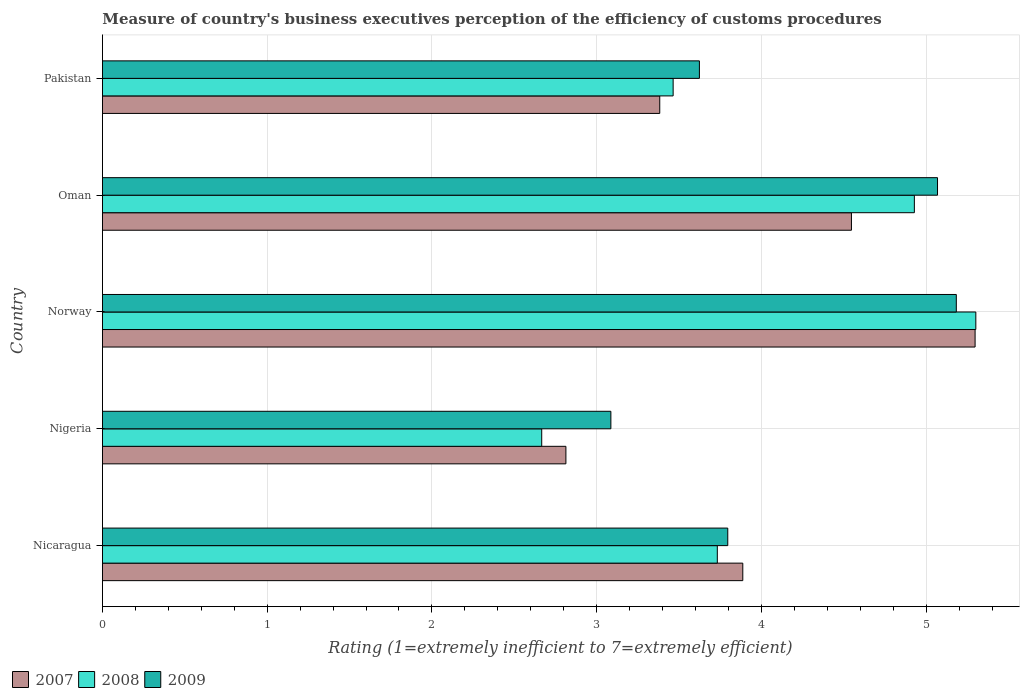How many different coloured bars are there?
Your answer should be compact. 3. How many bars are there on the 3rd tick from the top?
Offer a terse response. 3. How many bars are there on the 3rd tick from the bottom?
Your answer should be compact. 3. What is the label of the 2nd group of bars from the top?
Ensure brevity in your answer.  Oman. What is the rating of the efficiency of customs procedure in 2008 in Oman?
Your response must be concise. 4.93. Across all countries, what is the maximum rating of the efficiency of customs procedure in 2008?
Offer a terse response. 5.3. Across all countries, what is the minimum rating of the efficiency of customs procedure in 2008?
Offer a terse response. 2.67. In which country was the rating of the efficiency of customs procedure in 2007 maximum?
Your response must be concise. Norway. In which country was the rating of the efficiency of customs procedure in 2007 minimum?
Offer a very short reply. Nigeria. What is the total rating of the efficiency of customs procedure in 2009 in the graph?
Provide a succinct answer. 20.76. What is the difference between the rating of the efficiency of customs procedure in 2008 in Norway and that in Oman?
Provide a succinct answer. 0.37. What is the difference between the rating of the efficiency of customs procedure in 2009 in Pakistan and the rating of the efficiency of customs procedure in 2007 in Nigeria?
Give a very brief answer. 0.81. What is the average rating of the efficiency of customs procedure in 2008 per country?
Make the answer very short. 4.02. What is the difference between the rating of the efficiency of customs procedure in 2009 and rating of the efficiency of customs procedure in 2008 in Nigeria?
Provide a short and direct response. 0.42. In how many countries, is the rating of the efficiency of customs procedure in 2007 greater than 2.6 ?
Your answer should be very brief. 5. What is the ratio of the rating of the efficiency of customs procedure in 2008 in Nicaragua to that in Norway?
Offer a very short reply. 0.7. Is the rating of the efficiency of customs procedure in 2009 in Nicaragua less than that in Oman?
Your answer should be very brief. Yes. What is the difference between the highest and the second highest rating of the efficiency of customs procedure in 2009?
Make the answer very short. 0.11. What is the difference between the highest and the lowest rating of the efficiency of customs procedure in 2007?
Offer a terse response. 2.48. What does the 3rd bar from the top in Pakistan represents?
Provide a short and direct response. 2007. Is it the case that in every country, the sum of the rating of the efficiency of customs procedure in 2008 and rating of the efficiency of customs procedure in 2009 is greater than the rating of the efficiency of customs procedure in 2007?
Your answer should be very brief. Yes. Are all the bars in the graph horizontal?
Make the answer very short. Yes. Does the graph contain any zero values?
Your response must be concise. No. Does the graph contain grids?
Your answer should be compact. Yes. How many legend labels are there?
Provide a short and direct response. 3. What is the title of the graph?
Offer a very short reply. Measure of country's business executives perception of the efficiency of customs procedures. What is the label or title of the X-axis?
Offer a terse response. Rating (1=extremely inefficient to 7=extremely efficient). What is the label or title of the Y-axis?
Your answer should be very brief. Country. What is the Rating (1=extremely inefficient to 7=extremely efficient) in 2007 in Nicaragua?
Your response must be concise. 3.89. What is the Rating (1=extremely inefficient to 7=extremely efficient) of 2008 in Nicaragua?
Ensure brevity in your answer.  3.73. What is the Rating (1=extremely inefficient to 7=extremely efficient) of 2009 in Nicaragua?
Keep it short and to the point. 3.8. What is the Rating (1=extremely inefficient to 7=extremely efficient) of 2007 in Nigeria?
Your response must be concise. 2.81. What is the Rating (1=extremely inefficient to 7=extremely efficient) in 2008 in Nigeria?
Make the answer very short. 2.67. What is the Rating (1=extremely inefficient to 7=extremely efficient) of 2009 in Nigeria?
Give a very brief answer. 3.09. What is the Rating (1=extremely inefficient to 7=extremely efficient) of 2007 in Norway?
Provide a short and direct response. 5.3. What is the Rating (1=extremely inefficient to 7=extremely efficient) in 2008 in Norway?
Keep it short and to the point. 5.3. What is the Rating (1=extremely inefficient to 7=extremely efficient) of 2009 in Norway?
Make the answer very short. 5.18. What is the Rating (1=extremely inefficient to 7=extremely efficient) of 2007 in Oman?
Offer a very short reply. 4.55. What is the Rating (1=extremely inefficient to 7=extremely efficient) of 2008 in Oman?
Your answer should be compact. 4.93. What is the Rating (1=extremely inefficient to 7=extremely efficient) of 2009 in Oman?
Ensure brevity in your answer.  5.07. What is the Rating (1=extremely inefficient to 7=extremely efficient) in 2007 in Pakistan?
Keep it short and to the point. 3.38. What is the Rating (1=extremely inefficient to 7=extremely efficient) in 2008 in Pakistan?
Offer a terse response. 3.46. What is the Rating (1=extremely inefficient to 7=extremely efficient) of 2009 in Pakistan?
Provide a short and direct response. 3.62. Across all countries, what is the maximum Rating (1=extremely inefficient to 7=extremely efficient) of 2007?
Ensure brevity in your answer.  5.3. Across all countries, what is the maximum Rating (1=extremely inefficient to 7=extremely efficient) of 2008?
Provide a succinct answer. 5.3. Across all countries, what is the maximum Rating (1=extremely inefficient to 7=extremely efficient) in 2009?
Offer a terse response. 5.18. Across all countries, what is the minimum Rating (1=extremely inefficient to 7=extremely efficient) of 2007?
Ensure brevity in your answer.  2.81. Across all countries, what is the minimum Rating (1=extremely inefficient to 7=extremely efficient) in 2008?
Provide a short and direct response. 2.67. Across all countries, what is the minimum Rating (1=extremely inefficient to 7=extremely efficient) in 2009?
Your answer should be compact. 3.09. What is the total Rating (1=extremely inefficient to 7=extremely efficient) in 2007 in the graph?
Give a very brief answer. 19.93. What is the total Rating (1=extremely inefficient to 7=extremely efficient) of 2008 in the graph?
Make the answer very short. 20.09. What is the total Rating (1=extremely inefficient to 7=extremely efficient) of 2009 in the graph?
Provide a short and direct response. 20.76. What is the difference between the Rating (1=extremely inefficient to 7=extremely efficient) of 2007 in Nicaragua and that in Nigeria?
Your answer should be very brief. 1.07. What is the difference between the Rating (1=extremely inefficient to 7=extremely efficient) in 2008 in Nicaragua and that in Nigeria?
Offer a very short reply. 1.07. What is the difference between the Rating (1=extremely inefficient to 7=extremely efficient) of 2009 in Nicaragua and that in Nigeria?
Ensure brevity in your answer.  0.71. What is the difference between the Rating (1=extremely inefficient to 7=extremely efficient) in 2007 in Nicaragua and that in Norway?
Keep it short and to the point. -1.41. What is the difference between the Rating (1=extremely inefficient to 7=extremely efficient) of 2008 in Nicaragua and that in Norway?
Offer a terse response. -1.57. What is the difference between the Rating (1=extremely inefficient to 7=extremely efficient) in 2009 in Nicaragua and that in Norway?
Your answer should be very brief. -1.39. What is the difference between the Rating (1=extremely inefficient to 7=extremely efficient) of 2007 in Nicaragua and that in Oman?
Provide a succinct answer. -0.66. What is the difference between the Rating (1=extremely inefficient to 7=extremely efficient) in 2008 in Nicaragua and that in Oman?
Your answer should be very brief. -1.2. What is the difference between the Rating (1=extremely inefficient to 7=extremely efficient) of 2009 in Nicaragua and that in Oman?
Offer a very short reply. -1.27. What is the difference between the Rating (1=extremely inefficient to 7=extremely efficient) of 2007 in Nicaragua and that in Pakistan?
Your answer should be compact. 0.5. What is the difference between the Rating (1=extremely inefficient to 7=extremely efficient) in 2008 in Nicaragua and that in Pakistan?
Give a very brief answer. 0.27. What is the difference between the Rating (1=extremely inefficient to 7=extremely efficient) in 2009 in Nicaragua and that in Pakistan?
Offer a very short reply. 0.17. What is the difference between the Rating (1=extremely inefficient to 7=extremely efficient) in 2007 in Nigeria and that in Norway?
Give a very brief answer. -2.48. What is the difference between the Rating (1=extremely inefficient to 7=extremely efficient) of 2008 in Nigeria and that in Norway?
Make the answer very short. -2.64. What is the difference between the Rating (1=extremely inefficient to 7=extremely efficient) of 2009 in Nigeria and that in Norway?
Your response must be concise. -2.1. What is the difference between the Rating (1=extremely inefficient to 7=extremely efficient) of 2007 in Nigeria and that in Oman?
Provide a succinct answer. -1.73. What is the difference between the Rating (1=extremely inefficient to 7=extremely efficient) of 2008 in Nigeria and that in Oman?
Keep it short and to the point. -2.26. What is the difference between the Rating (1=extremely inefficient to 7=extremely efficient) of 2009 in Nigeria and that in Oman?
Provide a succinct answer. -1.98. What is the difference between the Rating (1=extremely inefficient to 7=extremely efficient) of 2007 in Nigeria and that in Pakistan?
Ensure brevity in your answer.  -0.57. What is the difference between the Rating (1=extremely inefficient to 7=extremely efficient) of 2008 in Nigeria and that in Pakistan?
Provide a succinct answer. -0.8. What is the difference between the Rating (1=extremely inefficient to 7=extremely efficient) of 2009 in Nigeria and that in Pakistan?
Offer a very short reply. -0.54. What is the difference between the Rating (1=extremely inefficient to 7=extremely efficient) of 2007 in Norway and that in Oman?
Give a very brief answer. 0.75. What is the difference between the Rating (1=extremely inefficient to 7=extremely efficient) in 2008 in Norway and that in Oman?
Provide a succinct answer. 0.37. What is the difference between the Rating (1=extremely inefficient to 7=extremely efficient) in 2009 in Norway and that in Oman?
Ensure brevity in your answer.  0.11. What is the difference between the Rating (1=extremely inefficient to 7=extremely efficient) of 2007 in Norway and that in Pakistan?
Make the answer very short. 1.91. What is the difference between the Rating (1=extremely inefficient to 7=extremely efficient) in 2008 in Norway and that in Pakistan?
Your answer should be very brief. 1.84. What is the difference between the Rating (1=extremely inefficient to 7=extremely efficient) in 2009 in Norway and that in Pakistan?
Your response must be concise. 1.56. What is the difference between the Rating (1=extremely inefficient to 7=extremely efficient) of 2007 in Oman and that in Pakistan?
Give a very brief answer. 1.16. What is the difference between the Rating (1=extremely inefficient to 7=extremely efficient) of 2008 in Oman and that in Pakistan?
Your response must be concise. 1.46. What is the difference between the Rating (1=extremely inefficient to 7=extremely efficient) of 2009 in Oman and that in Pakistan?
Offer a very short reply. 1.45. What is the difference between the Rating (1=extremely inefficient to 7=extremely efficient) in 2007 in Nicaragua and the Rating (1=extremely inefficient to 7=extremely efficient) in 2008 in Nigeria?
Offer a terse response. 1.22. What is the difference between the Rating (1=extremely inefficient to 7=extremely efficient) of 2007 in Nicaragua and the Rating (1=extremely inefficient to 7=extremely efficient) of 2009 in Nigeria?
Ensure brevity in your answer.  0.8. What is the difference between the Rating (1=extremely inefficient to 7=extremely efficient) in 2008 in Nicaragua and the Rating (1=extremely inefficient to 7=extremely efficient) in 2009 in Nigeria?
Your answer should be compact. 0.65. What is the difference between the Rating (1=extremely inefficient to 7=extremely efficient) in 2007 in Nicaragua and the Rating (1=extremely inefficient to 7=extremely efficient) in 2008 in Norway?
Keep it short and to the point. -1.41. What is the difference between the Rating (1=extremely inefficient to 7=extremely efficient) in 2007 in Nicaragua and the Rating (1=extremely inefficient to 7=extremely efficient) in 2009 in Norway?
Make the answer very short. -1.3. What is the difference between the Rating (1=extremely inefficient to 7=extremely efficient) in 2008 in Nicaragua and the Rating (1=extremely inefficient to 7=extremely efficient) in 2009 in Norway?
Keep it short and to the point. -1.45. What is the difference between the Rating (1=extremely inefficient to 7=extremely efficient) in 2007 in Nicaragua and the Rating (1=extremely inefficient to 7=extremely efficient) in 2008 in Oman?
Your answer should be very brief. -1.04. What is the difference between the Rating (1=extremely inefficient to 7=extremely efficient) of 2007 in Nicaragua and the Rating (1=extremely inefficient to 7=extremely efficient) of 2009 in Oman?
Your answer should be compact. -1.18. What is the difference between the Rating (1=extremely inefficient to 7=extremely efficient) in 2008 in Nicaragua and the Rating (1=extremely inefficient to 7=extremely efficient) in 2009 in Oman?
Offer a terse response. -1.34. What is the difference between the Rating (1=extremely inefficient to 7=extremely efficient) of 2007 in Nicaragua and the Rating (1=extremely inefficient to 7=extremely efficient) of 2008 in Pakistan?
Provide a short and direct response. 0.42. What is the difference between the Rating (1=extremely inefficient to 7=extremely efficient) of 2007 in Nicaragua and the Rating (1=extremely inefficient to 7=extremely efficient) of 2009 in Pakistan?
Provide a short and direct response. 0.26. What is the difference between the Rating (1=extremely inefficient to 7=extremely efficient) of 2008 in Nicaragua and the Rating (1=extremely inefficient to 7=extremely efficient) of 2009 in Pakistan?
Your answer should be compact. 0.11. What is the difference between the Rating (1=extremely inefficient to 7=extremely efficient) of 2007 in Nigeria and the Rating (1=extremely inefficient to 7=extremely efficient) of 2008 in Norway?
Offer a very short reply. -2.49. What is the difference between the Rating (1=extremely inefficient to 7=extremely efficient) in 2007 in Nigeria and the Rating (1=extremely inefficient to 7=extremely efficient) in 2009 in Norway?
Offer a very short reply. -2.37. What is the difference between the Rating (1=extremely inefficient to 7=extremely efficient) of 2008 in Nigeria and the Rating (1=extremely inefficient to 7=extremely efficient) of 2009 in Norway?
Ensure brevity in your answer.  -2.52. What is the difference between the Rating (1=extremely inefficient to 7=extremely efficient) of 2007 in Nigeria and the Rating (1=extremely inefficient to 7=extremely efficient) of 2008 in Oman?
Your answer should be compact. -2.12. What is the difference between the Rating (1=extremely inefficient to 7=extremely efficient) of 2007 in Nigeria and the Rating (1=extremely inefficient to 7=extremely efficient) of 2009 in Oman?
Make the answer very short. -2.26. What is the difference between the Rating (1=extremely inefficient to 7=extremely efficient) of 2008 in Nigeria and the Rating (1=extremely inefficient to 7=extremely efficient) of 2009 in Oman?
Your answer should be compact. -2.4. What is the difference between the Rating (1=extremely inefficient to 7=extremely efficient) of 2007 in Nigeria and the Rating (1=extremely inefficient to 7=extremely efficient) of 2008 in Pakistan?
Offer a terse response. -0.65. What is the difference between the Rating (1=extremely inefficient to 7=extremely efficient) in 2007 in Nigeria and the Rating (1=extremely inefficient to 7=extremely efficient) in 2009 in Pakistan?
Ensure brevity in your answer.  -0.81. What is the difference between the Rating (1=extremely inefficient to 7=extremely efficient) in 2008 in Nigeria and the Rating (1=extremely inefficient to 7=extremely efficient) in 2009 in Pakistan?
Offer a terse response. -0.96. What is the difference between the Rating (1=extremely inefficient to 7=extremely efficient) in 2007 in Norway and the Rating (1=extremely inefficient to 7=extremely efficient) in 2008 in Oman?
Offer a terse response. 0.37. What is the difference between the Rating (1=extremely inefficient to 7=extremely efficient) of 2007 in Norway and the Rating (1=extremely inefficient to 7=extremely efficient) of 2009 in Oman?
Offer a terse response. 0.23. What is the difference between the Rating (1=extremely inefficient to 7=extremely efficient) of 2008 in Norway and the Rating (1=extremely inefficient to 7=extremely efficient) of 2009 in Oman?
Make the answer very short. 0.23. What is the difference between the Rating (1=extremely inefficient to 7=extremely efficient) of 2007 in Norway and the Rating (1=extremely inefficient to 7=extremely efficient) of 2008 in Pakistan?
Your response must be concise. 1.83. What is the difference between the Rating (1=extremely inefficient to 7=extremely efficient) of 2007 in Norway and the Rating (1=extremely inefficient to 7=extremely efficient) of 2009 in Pakistan?
Your response must be concise. 1.67. What is the difference between the Rating (1=extremely inefficient to 7=extremely efficient) of 2008 in Norway and the Rating (1=extremely inefficient to 7=extremely efficient) of 2009 in Pakistan?
Your response must be concise. 1.68. What is the difference between the Rating (1=extremely inefficient to 7=extremely efficient) in 2007 in Oman and the Rating (1=extremely inefficient to 7=extremely efficient) in 2008 in Pakistan?
Give a very brief answer. 1.08. What is the difference between the Rating (1=extremely inefficient to 7=extremely efficient) of 2007 in Oman and the Rating (1=extremely inefficient to 7=extremely efficient) of 2009 in Pakistan?
Your answer should be compact. 0.92. What is the difference between the Rating (1=extremely inefficient to 7=extremely efficient) in 2008 in Oman and the Rating (1=extremely inefficient to 7=extremely efficient) in 2009 in Pakistan?
Ensure brevity in your answer.  1.3. What is the average Rating (1=extremely inefficient to 7=extremely efficient) in 2007 per country?
Provide a short and direct response. 3.99. What is the average Rating (1=extremely inefficient to 7=extremely efficient) of 2008 per country?
Keep it short and to the point. 4.02. What is the average Rating (1=extremely inefficient to 7=extremely efficient) of 2009 per country?
Your answer should be compact. 4.15. What is the difference between the Rating (1=extremely inefficient to 7=extremely efficient) in 2007 and Rating (1=extremely inefficient to 7=extremely efficient) in 2008 in Nicaragua?
Give a very brief answer. 0.15. What is the difference between the Rating (1=extremely inefficient to 7=extremely efficient) of 2007 and Rating (1=extremely inefficient to 7=extremely efficient) of 2009 in Nicaragua?
Keep it short and to the point. 0.09. What is the difference between the Rating (1=extremely inefficient to 7=extremely efficient) in 2008 and Rating (1=extremely inefficient to 7=extremely efficient) in 2009 in Nicaragua?
Ensure brevity in your answer.  -0.06. What is the difference between the Rating (1=extremely inefficient to 7=extremely efficient) of 2007 and Rating (1=extremely inefficient to 7=extremely efficient) of 2008 in Nigeria?
Provide a short and direct response. 0.15. What is the difference between the Rating (1=extremely inefficient to 7=extremely efficient) of 2007 and Rating (1=extremely inefficient to 7=extremely efficient) of 2009 in Nigeria?
Provide a short and direct response. -0.27. What is the difference between the Rating (1=extremely inefficient to 7=extremely efficient) of 2008 and Rating (1=extremely inefficient to 7=extremely efficient) of 2009 in Nigeria?
Provide a short and direct response. -0.42. What is the difference between the Rating (1=extremely inefficient to 7=extremely efficient) of 2007 and Rating (1=extremely inefficient to 7=extremely efficient) of 2008 in Norway?
Your answer should be compact. -0. What is the difference between the Rating (1=extremely inefficient to 7=extremely efficient) of 2007 and Rating (1=extremely inefficient to 7=extremely efficient) of 2009 in Norway?
Provide a short and direct response. 0.11. What is the difference between the Rating (1=extremely inefficient to 7=extremely efficient) in 2008 and Rating (1=extremely inefficient to 7=extremely efficient) in 2009 in Norway?
Offer a terse response. 0.12. What is the difference between the Rating (1=extremely inefficient to 7=extremely efficient) in 2007 and Rating (1=extremely inefficient to 7=extremely efficient) in 2008 in Oman?
Offer a very short reply. -0.38. What is the difference between the Rating (1=extremely inefficient to 7=extremely efficient) of 2007 and Rating (1=extremely inefficient to 7=extremely efficient) of 2009 in Oman?
Your answer should be compact. -0.52. What is the difference between the Rating (1=extremely inefficient to 7=extremely efficient) of 2008 and Rating (1=extremely inefficient to 7=extremely efficient) of 2009 in Oman?
Keep it short and to the point. -0.14. What is the difference between the Rating (1=extremely inefficient to 7=extremely efficient) in 2007 and Rating (1=extremely inefficient to 7=extremely efficient) in 2008 in Pakistan?
Offer a terse response. -0.08. What is the difference between the Rating (1=extremely inefficient to 7=extremely efficient) of 2007 and Rating (1=extremely inefficient to 7=extremely efficient) of 2009 in Pakistan?
Keep it short and to the point. -0.24. What is the difference between the Rating (1=extremely inefficient to 7=extremely efficient) in 2008 and Rating (1=extremely inefficient to 7=extremely efficient) in 2009 in Pakistan?
Your response must be concise. -0.16. What is the ratio of the Rating (1=extremely inefficient to 7=extremely efficient) in 2007 in Nicaragua to that in Nigeria?
Your answer should be compact. 1.38. What is the ratio of the Rating (1=extremely inefficient to 7=extremely efficient) of 2008 in Nicaragua to that in Nigeria?
Keep it short and to the point. 1.4. What is the ratio of the Rating (1=extremely inefficient to 7=extremely efficient) in 2009 in Nicaragua to that in Nigeria?
Provide a short and direct response. 1.23. What is the ratio of the Rating (1=extremely inefficient to 7=extremely efficient) in 2007 in Nicaragua to that in Norway?
Provide a short and direct response. 0.73. What is the ratio of the Rating (1=extremely inefficient to 7=extremely efficient) of 2008 in Nicaragua to that in Norway?
Give a very brief answer. 0.7. What is the ratio of the Rating (1=extremely inefficient to 7=extremely efficient) of 2009 in Nicaragua to that in Norway?
Keep it short and to the point. 0.73. What is the ratio of the Rating (1=extremely inefficient to 7=extremely efficient) in 2007 in Nicaragua to that in Oman?
Your answer should be very brief. 0.85. What is the ratio of the Rating (1=extremely inefficient to 7=extremely efficient) of 2008 in Nicaragua to that in Oman?
Your answer should be very brief. 0.76. What is the ratio of the Rating (1=extremely inefficient to 7=extremely efficient) of 2009 in Nicaragua to that in Oman?
Provide a succinct answer. 0.75. What is the ratio of the Rating (1=extremely inefficient to 7=extremely efficient) of 2007 in Nicaragua to that in Pakistan?
Give a very brief answer. 1.15. What is the ratio of the Rating (1=extremely inefficient to 7=extremely efficient) of 2008 in Nicaragua to that in Pakistan?
Provide a short and direct response. 1.08. What is the ratio of the Rating (1=extremely inefficient to 7=extremely efficient) in 2009 in Nicaragua to that in Pakistan?
Your response must be concise. 1.05. What is the ratio of the Rating (1=extremely inefficient to 7=extremely efficient) in 2007 in Nigeria to that in Norway?
Provide a succinct answer. 0.53. What is the ratio of the Rating (1=extremely inefficient to 7=extremely efficient) in 2008 in Nigeria to that in Norway?
Your answer should be very brief. 0.5. What is the ratio of the Rating (1=extremely inefficient to 7=extremely efficient) in 2009 in Nigeria to that in Norway?
Your answer should be very brief. 0.6. What is the ratio of the Rating (1=extremely inefficient to 7=extremely efficient) in 2007 in Nigeria to that in Oman?
Offer a very short reply. 0.62. What is the ratio of the Rating (1=extremely inefficient to 7=extremely efficient) of 2008 in Nigeria to that in Oman?
Offer a very short reply. 0.54. What is the ratio of the Rating (1=extremely inefficient to 7=extremely efficient) in 2009 in Nigeria to that in Oman?
Give a very brief answer. 0.61. What is the ratio of the Rating (1=extremely inefficient to 7=extremely efficient) of 2007 in Nigeria to that in Pakistan?
Offer a terse response. 0.83. What is the ratio of the Rating (1=extremely inefficient to 7=extremely efficient) in 2008 in Nigeria to that in Pakistan?
Make the answer very short. 0.77. What is the ratio of the Rating (1=extremely inefficient to 7=extremely efficient) of 2009 in Nigeria to that in Pakistan?
Offer a very short reply. 0.85. What is the ratio of the Rating (1=extremely inefficient to 7=extremely efficient) in 2007 in Norway to that in Oman?
Provide a succinct answer. 1.17. What is the ratio of the Rating (1=extremely inefficient to 7=extremely efficient) in 2008 in Norway to that in Oman?
Provide a succinct answer. 1.08. What is the ratio of the Rating (1=extremely inefficient to 7=extremely efficient) of 2009 in Norway to that in Oman?
Make the answer very short. 1.02. What is the ratio of the Rating (1=extremely inefficient to 7=extremely efficient) in 2007 in Norway to that in Pakistan?
Offer a very short reply. 1.57. What is the ratio of the Rating (1=extremely inefficient to 7=extremely efficient) in 2008 in Norway to that in Pakistan?
Keep it short and to the point. 1.53. What is the ratio of the Rating (1=extremely inefficient to 7=extremely efficient) of 2009 in Norway to that in Pakistan?
Offer a terse response. 1.43. What is the ratio of the Rating (1=extremely inefficient to 7=extremely efficient) in 2007 in Oman to that in Pakistan?
Offer a terse response. 1.34. What is the ratio of the Rating (1=extremely inefficient to 7=extremely efficient) of 2008 in Oman to that in Pakistan?
Your response must be concise. 1.42. What is the ratio of the Rating (1=extremely inefficient to 7=extremely efficient) in 2009 in Oman to that in Pakistan?
Provide a succinct answer. 1.4. What is the difference between the highest and the second highest Rating (1=extremely inefficient to 7=extremely efficient) of 2007?
Keep it short and to the point. 0.75. What is the difference between the highest and the second highest Rating (1=extremely inefficient to 7=extremely efficient) of 2008?
Provide a short and direct response. 0.37. What is the difference between the highest and the second highest Rating (1=extremely inefficient to 7=extremely efficient) of 2009?
Provide a short and direct response. 0.11. What is the difference between the highest and the lowest Rating (1=extremely inefficient to 7=extremely efficient) in 2007?
Your answer should be compact. 2.48. What is the difference between the highest and the lowest Rating (1=extremely inefficient to 7=extremely efficient) in 2008?
Make the answer very short. 2.64. What is the difference between the highest and the lowest Rating (1=extremely inefficient to 7=extremely efficient) in 2009?
Keep it short and to the point. 2.1. 